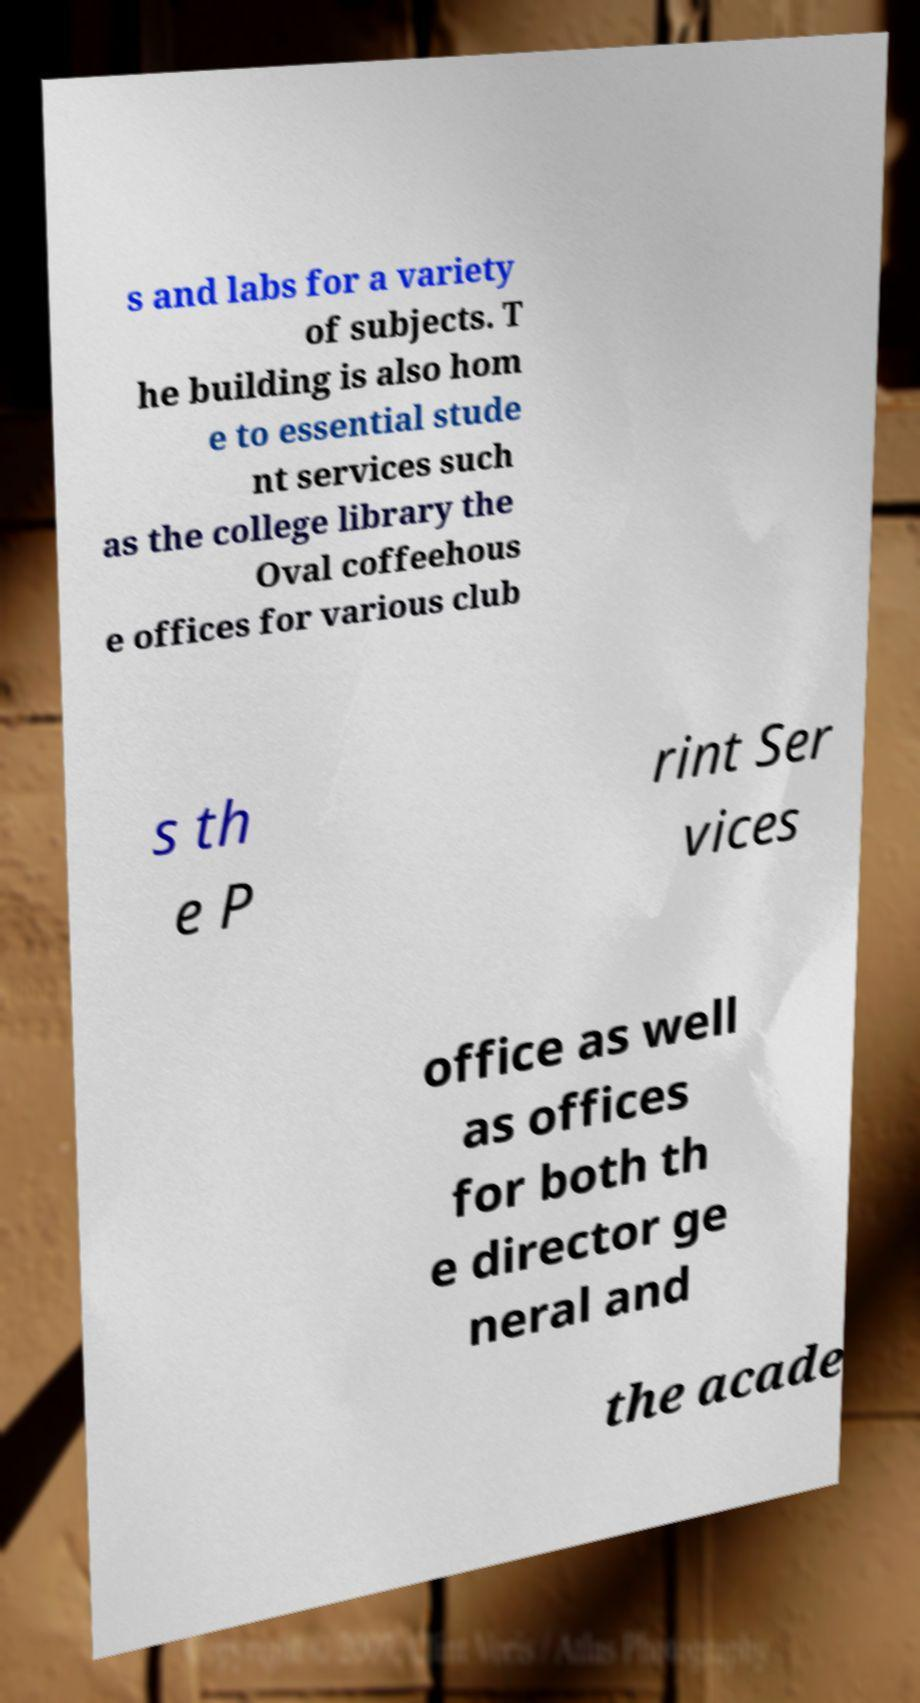What messages or text are displayed in this image? I need them in a readable, typed format. s and labs for a variety of subjects. T he building is also hom e to essential stude nt services such as the college library the Oval coffeehous e offices for various club s th e P rint Ser vices office as well as offices for both th e director ge neral and the acade 